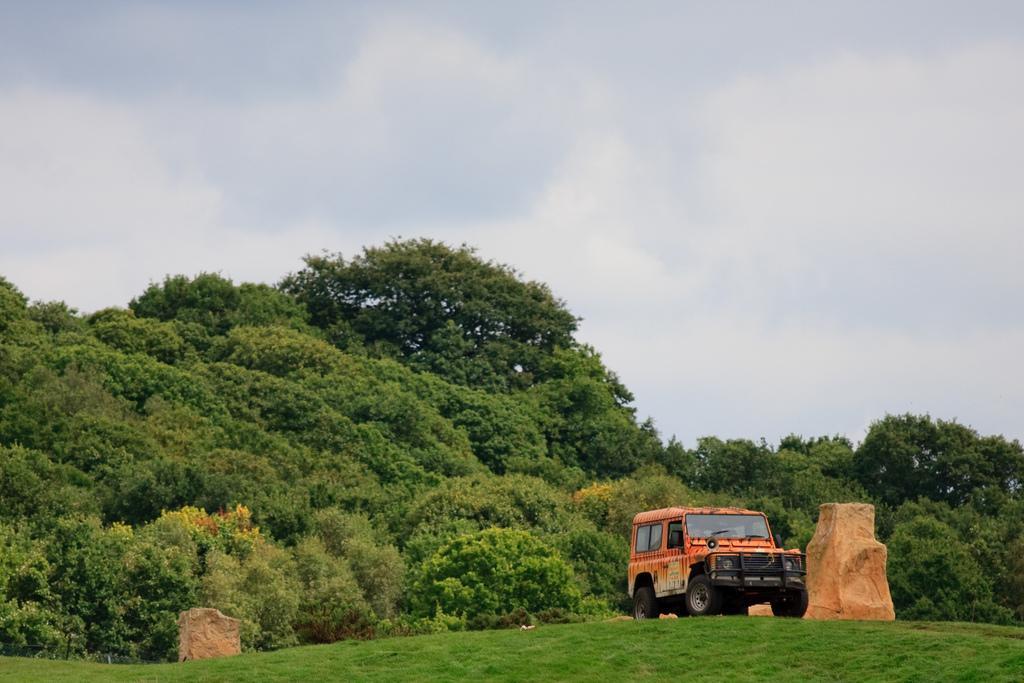Can you describe this image briefly? Sky is cloudy. Land is covered with grass. Background there are trees and vehicle. 